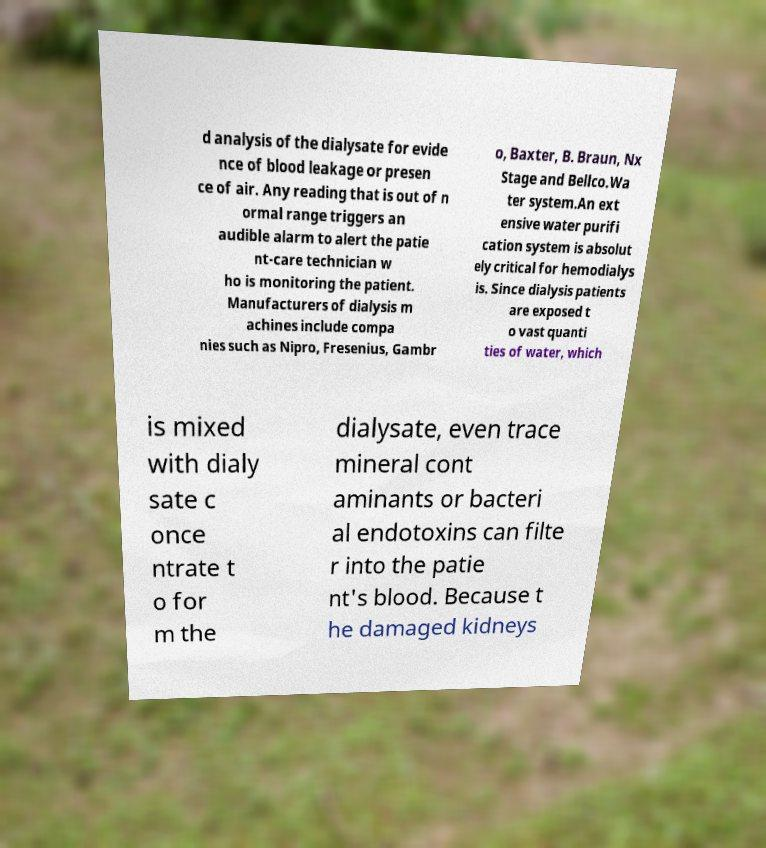Please read and relay the text visible in this image. What does it say? d analysis of the dialysate for evide nce of blood leakage or presen ce of air. Any reading that is out of n ormal range triggers an audible alarm to alert the patie nt-care technician w ho is monitoring the patient. Manufacturers of dialysis m achines include compa nies such as Nipro, Fresenius, Gambr o, Baxter, B. Braun, Nx Stage and Bellco.Wa ter system.An ext ensive water purifi cation system is absolut ely critical for hemodialys is. Since dialysis patients are exposed t o vast quanti ties of water, which is mixed with dialy sate c once ntrate t o for m the dialysate, even trace mineral cont aminants or bacteri al endotoxins can filte r into the patie nt's blood. Because t he damaged kidneys 